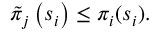<formula> <loc_0><loc_0><loc_500><loc_500>\tilde { \pi } _ { j } \left ( s _ { i } \right ) \leq \pi _ { i } ( s _ { i } ) .</formula> 